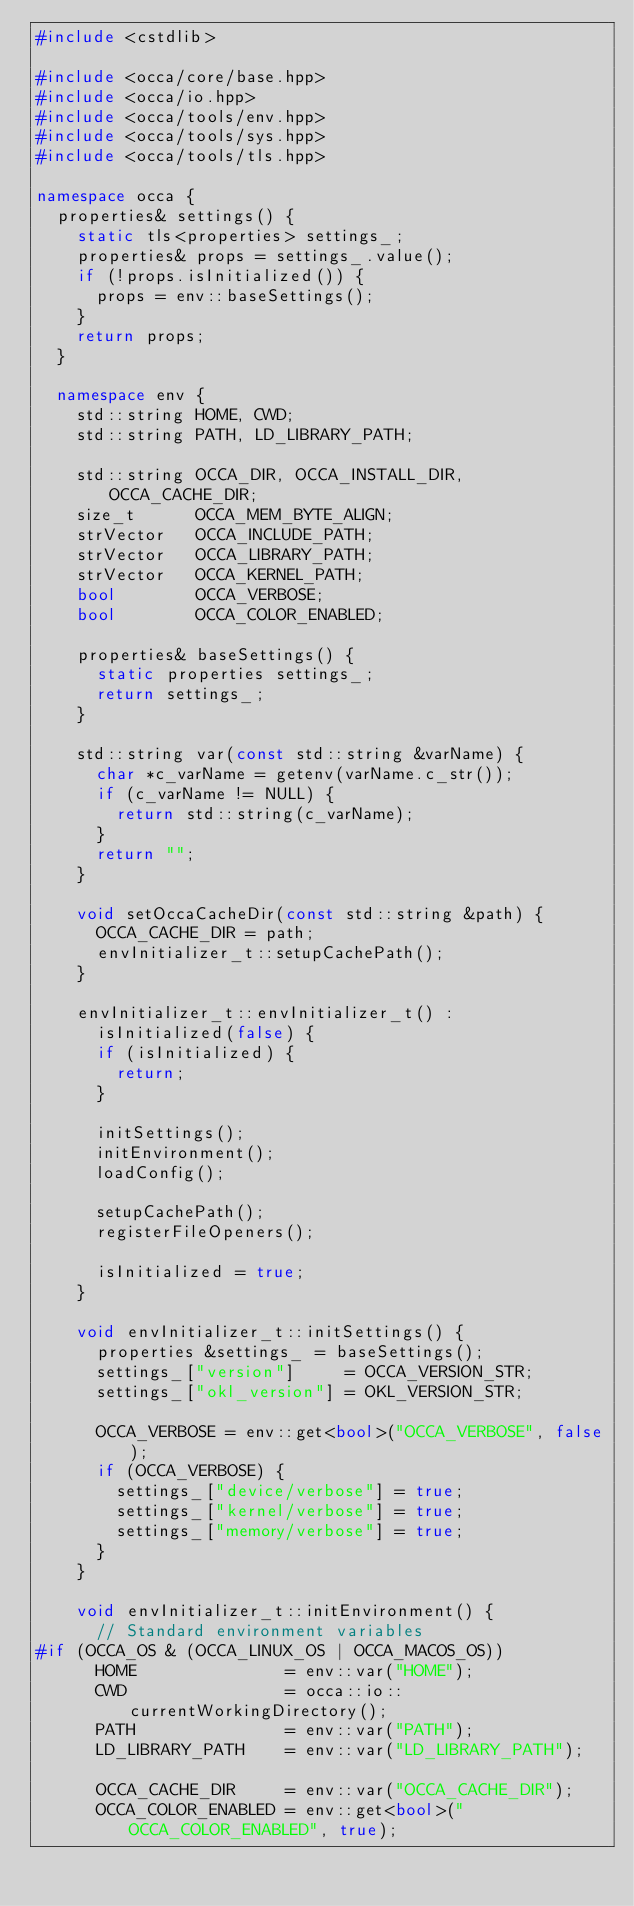Convert code to text. <code><loc_0><loc_0><loc_500><loc_500><_C++_>#include <cstdlib>

#include <occa/core/base.hpp>
#include <occa/io.hpp>
#include <occa/tools/env.hpp>
#include <occa/tools/sys.hpp>
#include <occa/tools/tls.hpp>

namespace occa {
  properties& settings() {
    static tls<properties> settings_;
    properties& props = settings_.value();
    if (!props.isInitialized()) {
      props = env::baseSettings();
    }
    return props;
  }

  namespace env {
    std::string HOME, CWD;
    std::string PATH, LD_LIBRARY_PATH;

    std::string OCCA_DIR, OCCA_INSTALL_DIR, OCCA_CACHE_DIR;
    size_t      OCCA_MEM_BYTE_ALIGN;
    strVector   OCCA_INCLUDE_PATH;
    strVector   OCCA_LIBRARY_PATH;
    strVector   OCCA_KERNEL_PATH;
    bool        OCCA_VERBOSE;
    bool        OCCA_COLOR_ENABLED;

    properties& baseSettings() {
      static properties settings_;
      return settings_;
    }

    std::string var(const std::string &varName) {
      char *c_varName = getenv(varName.c_str());
      if (c_varName != NULL) {
        return std::string(c_varName);
      }
      return "";
    }

    void setOccaCacheDir(const std::string &path) {
      OCCA_CACHE_DIR = path;
      envInitializer_t::setupCachePath();
    }

    envInitializer_t::envInitializer_t() :
      isInitialized(false) {
      if (isInitialized) {
        return;
      }

      initSettings();
      initEnvironment();
      loadConfig();

      setupCachePath();
      registerFileOpeners();

      isInitialized = true;
    }

    void envInitializer_t::initSettings() {
      properties &settings_ = baseSettings();
      settings_["version"]     = OCCA_VERSION_STR;
      settings_["okl_version"] = OKL_VERSION_STR;

      OCCA_VERBOSE = env::get<bool>("OCCA_VERBOSE", false);
      if (OCCA_VERBOSE) {
        settings_["device/verbose"] = true;
        settings_["kernel/verbose"] = true;
        settings_["memory/verbose"] = true;
      }
    }

    void envInitializer_t::initEnvironment() {
      // Standard environment variables
#if (OCCA_OS & (OCCA_LINUX_OS | OCCA_MACOS_OS))
      HOME               = env::var("HOME");
      CWD                = occa::io::currentWorkingDirectory();
      PATH               = env::var("PATH");
      LD_LIBRARY_PATH    = env::var("LD_LIBRARY_PATH");

      OCCA_CACHE_DIR     = env::var("OCCA_CACHE_DIR");
      OCCA_COLOR_ENABLED = env::get<bool>("OCCA_COLOR_ENABLED", true);
</code> 